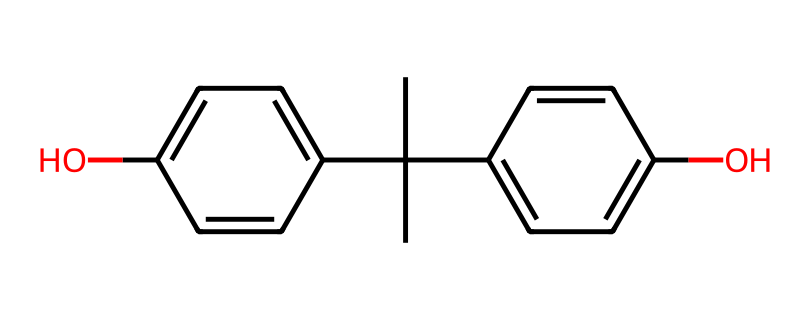What type of compound is represented by this structure? The chemical structure consists of hydroxyl groups attached to aromatic rings, which classifies it as a phenol.
Answer: phenol How many hydroxyl (–OH) groups are present? The chemical has two hydroxyl groups, as indicated by the two occurrences of the –OH functional group in the structure.
Answer: two What is the total number of carbon atoms in the structure? By counting the carbon atoms in the structure, there are 15 carbon atoms present, derived from both the rings and the isopropyl group.
Answer: fifteen Does this compound contain any alkyl groups? There is an isopropyl group attached to one of the aromatic rings, which classifies it as an alkyl group in the structure.
Answer: isopropyl How many aromatic rings can you identify in this compound? The structure shows two distinct aromatic rings, each represented by a cyclic structure with alternating double bonds.
Answer: two What is the significance of the hydroxyl groups in bisphenol A? The hydroxyl groups are responsible for the compound's ability to hydrogen bond, affecting its solubility and reactivity.
Answer: hydrogen bonding What property might the presence of aromatic rings confer to bisphenol A? The aromatic rings contribute to increased stability and hydrophobicity due to their structure, which can affect the interactions with water and other molecules.
Answer: stability and hydrophobicity 